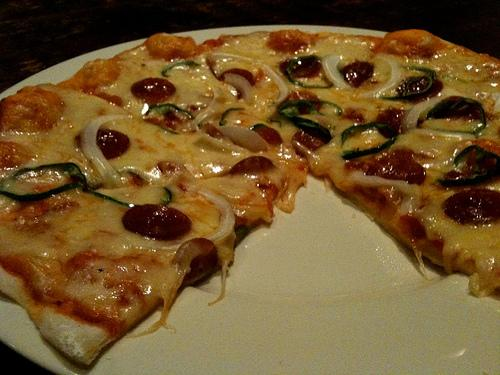Evaluate the image quality in terms of clarity and details of objects. The image quality is detailed and clear, as most objects, like the pizza toppings, are easily identifiable. Describe the image's overall sentiment, as it relates to the state of the pizza. The image has a casual and relaxed sentiment, as the pizza is enjoyed and has a slice missing, indicating a shared mealtime. Identify the primary food item depicted in the image and describe its condition. The primary food item is a pizza with a missing slice, covered in melted cheese, pepperoni, and green peppers on a white plate. Explain the current state of the pizza and the possible cause for it. A slice of the pizza is missing, possibly because it has been eaten or removed from the plate. Name the primary object in this image and describe its components. The primary object is a pizza, consisting of a crust, red sauce, melted cheese, pepperoni, and green peppers. What kind of task would involve determining if there is any residue of grease on the plate? An image quality assessment task could involve determining if there is any grease residue on the plate. What reasoning task may involve understanding how the pizza's state influences people's perception about it? The complex reasoning task may involve understanding how the missing slice of pizza impacts people's perception of the pizza's freshness or appeal. What item on the plate does not belong to the pizza? There are no items on the plate that do not belong to the pizza. Count the number of pepperoni slices visible on the pizza. There are seven visible pepperoni slices on the pizza. Can you find a blue onion slice in the image? There are slices of onion, but none in blue color. Is there any purple cheese on the pizza? The image mentions melted cheese, but it doesn't specify the color as purple. Is there a man surfing on a red surfboard in the image? There is no image of a man surfing on a surfboard in the image. Can you see a black dinner plate in the image? The image includes a white dinner plate on which the pizza is placed, but no black dinner plate is mentioned. Is there a yellow slice of pepperoni in the image? There are only red slices of pepperoni mentioned, not a yellow one. Does the pizza have any pink pesto on it? The image does not mention any pesto on the pizza. 